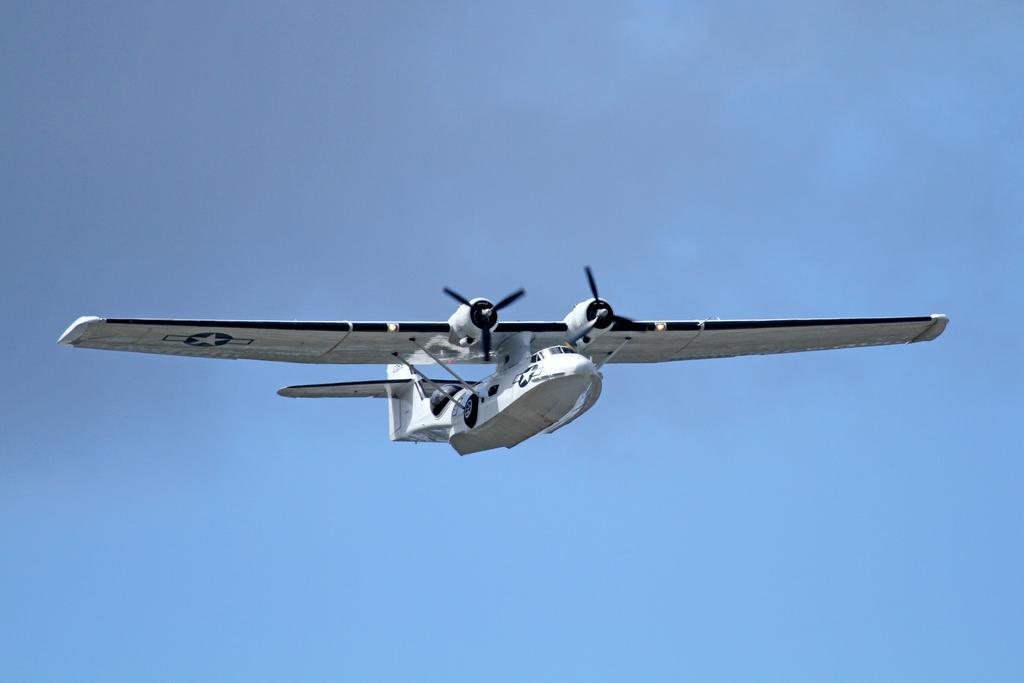Please provide a concise description of this image. In this image I can see aircraft and the sky visible in the middle. 